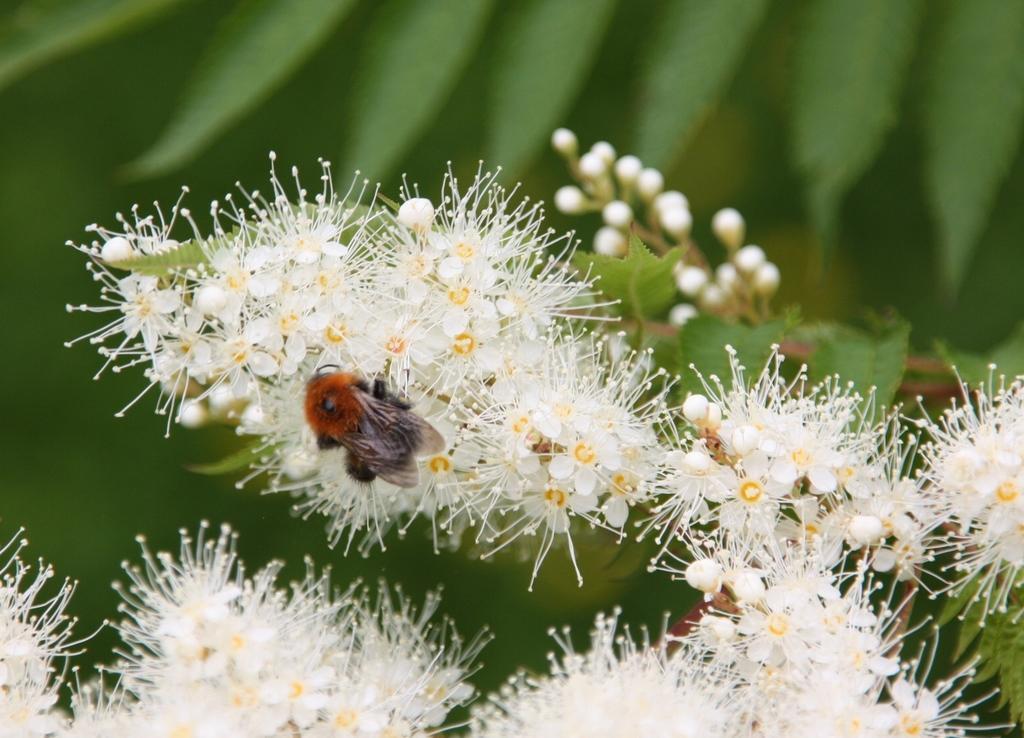Could you give a brief overview of what you see in this image? We can see white flowers and buds and we can see insect on this flower. In the background it is green color. 